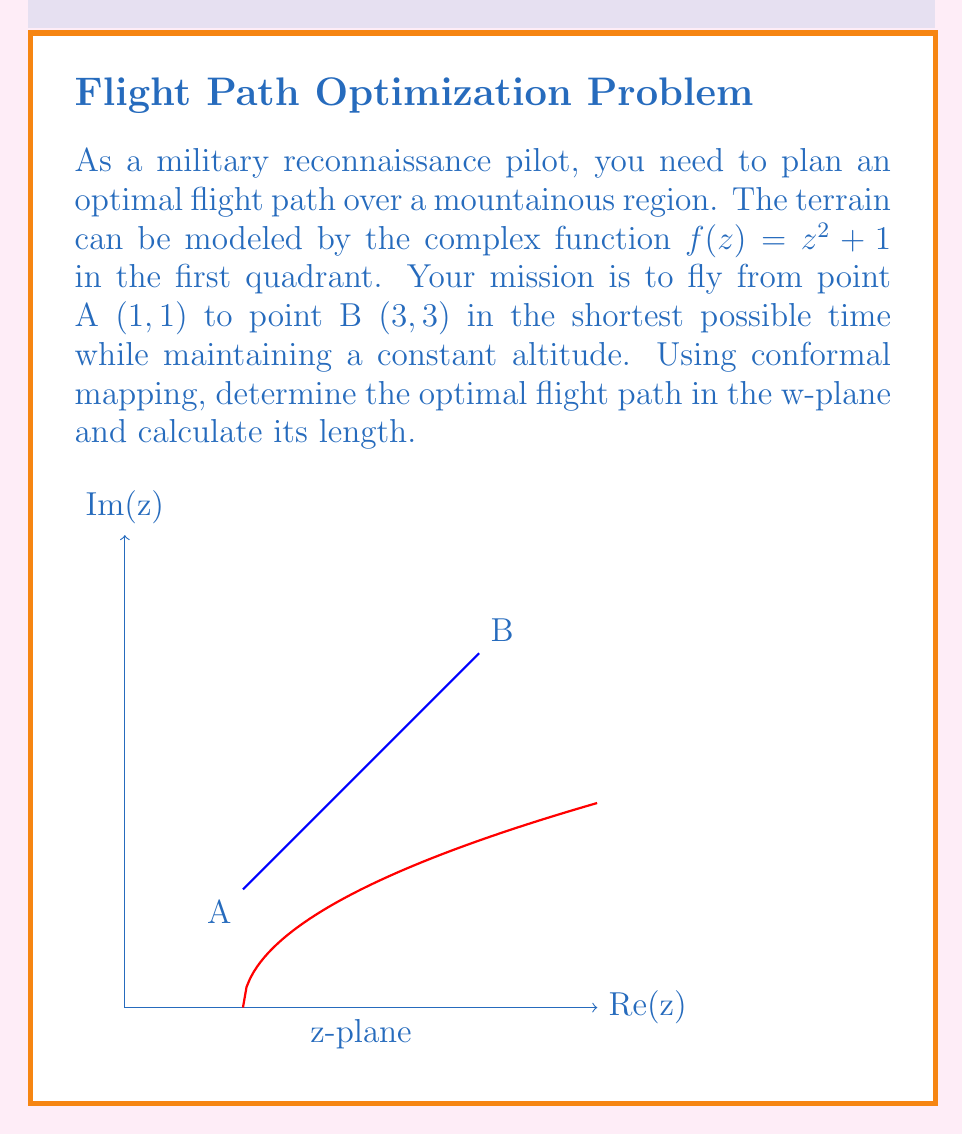Can you solve this math problem? Let's approach this step-by-step:

1) The conformal mapping $w = f(z) = z^2 + 1$ transforms the z-plane to the w-plane.

2) In the w-plane, points A and B transform to:
   $w_A = f(1+i) = (1+i)^2 + 1 = 1 + 2i + i^2 + 1 = 1 + 2i$
   $w_B = f(3+3i) = (3+3i)^2 + 1 = 9 + 18i - 9 + 1 = 1 + 18i$

3) In the w-plane, the shortest path between two points is a straight line. This is our optimal flight path in the transformed plane.

4) The vector representing this path in the w-plane is:
   $\vec{v} = w_B - w_A = (1 + 18i) - (1 + 2i) = 16i$

5) The length of this path in the w-plane is:
   $L_w = |\vec{v}| = |16i| = 16$

6) To find the actual length in the z-plane, we need to use the formula:
   $L_z = \int_{z_A}^{z_B} |f'(z)| dz$

   where $f'(z) = 2z$

7) Along the path from A to B in the z-plane, $z = x + xi$ (because y = x in the first quadrant)

8) Therefore, $|f'(z)| = |2z| = 2|z| = 2\sqrt{2}x$

9) The integral becomes:
   $L_z = \int_1^3 2\sqrt{2}x dx = 2\sqrt{2} [\frac{x^2}{2}]_1^3 = 2\sqrt{2} (\frac{9}{2} - \frac{1}{2}) = 8\sqrt{2}$

Thus, the optimal flight path in the z-plane corresponds to the straight line in the w-plane, and its length in the z-plane is $8\sqrt{2}$.
Answer: $8\sqrt{2}$ 